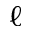<formula> <loc_0><loc_0><loc_500><loc_500>\ell</formula> 